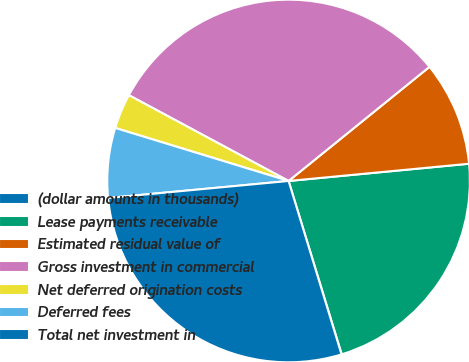Convert chart. <chart><loc_0><loc_0><loc_500><loc_500><pie_chart><fcel>(dollar amounts in thousands)<fcel>Lease payments receivable<fcel>Estimated residual value of<fcel>Gross investment in commercial<fcel>Net deferred origination costs<fcel>Deferred fees<fcel>Total net investment in<nl><fcel>0.02%<fcel>21.78%<fcel>9.32%<fcel>31.32%<fcel>3.12%<fcel>6.22%<fcel>28.22%<nl></chart> 